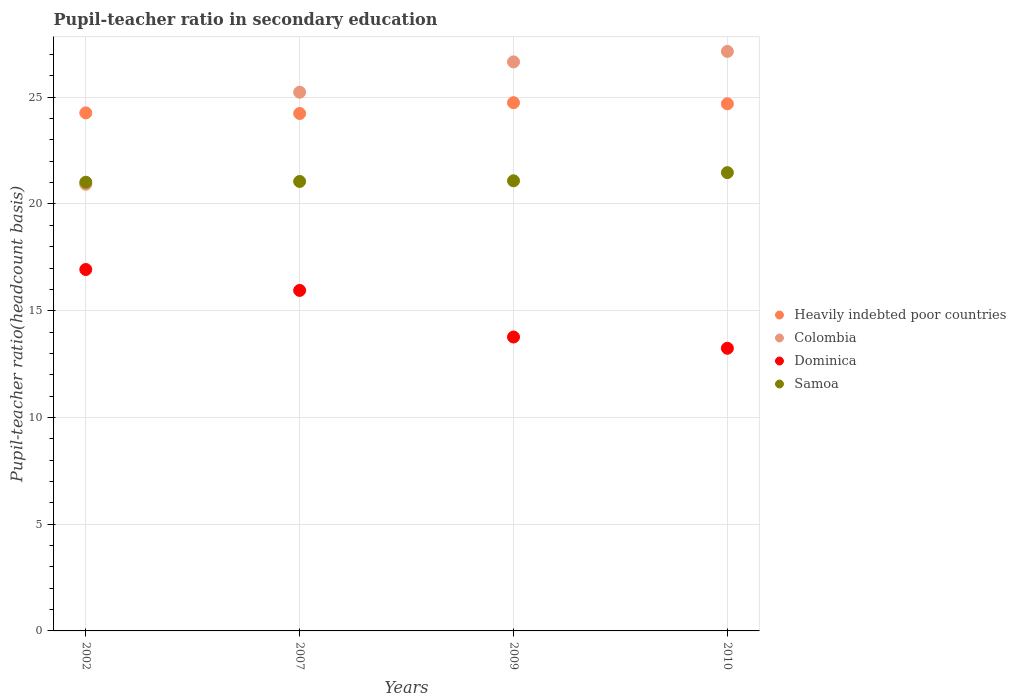What is the pupil-teacher ratio in secondary education in Dominica in 2007?
Your answer should be very brief. 15.95. Across all years, what is the maximum pupil-teacher ratio in secondary education in Colombia?
Your response must be concise. 27.15. Across all years, what is the minimum pupil-teacher ratio in secondary education in Dominica?
Give a very brief answer. 13.24. In which year was the pupil-teacher ratio in secondary education in Dominica maximum?
Offer a very short reply. 2002. In which year was the pupil-teacher ratio in secondary education in Heavily indebted poor countries minimum?
Your response must be concise. 2007. What is the total pupil-teacher ratio in secondary education in Samoa in the graph?
Give a very brief answer. 84.63. What is the difference between the pupil-teacher ratio in secondary education in Colombia in 2007 and that in 2009?
Ensure brevity in your answer.  -1.42. What is the difference between the pupil-teacher ratio in secondary education in Heavily indebted poor countries in 2007 and the pupil-teacher ratio in secondary education in Samoa in 2009?
Your answer should be compact. 3.15. What is the average pupil-teacher ratio in secondary education in Heavily indebted poor countries per year?
Provide a short and direct response. 24.49. In the year 2009, what is the difference between the pupil-teacher ratio in secondary education in Heavily indebted poor countries and pupil-teacher ratio in secondary education in Colombia?
Your response must be concise. -1.91. In how many years, is the pupil-teacher ratio in secondary education in Samoa greater than 11?
Provide a short and direct response. 4. What is the ratio of the pupil-teacher ratio in secondary education in Dominica in 2007 to that in 2010?
Ensure brevity in your answer.  1.2. Is the pupil-teacher ratio in secondary education in Heavily indebted poor countries in 2007 less than that in 2010?
Provide a succinct answer. Yes. What is the difference between the highest and the second highest pupil-teacher ratio in secondary education in Heavily indebted poor countries?
Provide a succinct answer. 0.05. What is the difference between the highest and the lowest pupil-teacher ratio in secondary education in Samoa?
Your response must be concise. 0.45. Is the sum of the pupil-teacher ratio in secondary education in Colombia in 2009 and 2010 greater than the maximum pupil-teacher ratio in secondary education in Samoa across all years?
Ensure brevity in your answer.  Yes. Is it the case that in every year, the sum of the pupil-teacher ratio in secondary education in Samoa and pupil-teacher ratio in secondary education in Dominica  is greater than the sum of pupil-teacher ratio in secondary education in Heavily indebted poor countries and pupil-teacher ratio in secondary education in Colombia?
Your answer should be very brief. No. Is the pupil-teacher ratio in secondary education in Colombia strictly greater than the pupil-teacher ratio in secondary education in Samoa over the years?
Make the answer very short. No. How many dotlines are there?
Ensure brevity in your answer.  4. Are the values on the major ticks of Y-axis written in scientific E-notation?
Your response must be concise. No. Where does the legend appear in the graph?
Offer a terse response. Center right. What is the title of the graph?
Provide a succinct answer. Pupil-teacher ratio in secondary education. Does "Sudan" appear as one of the legend labels in the graph?
Keep it short and to the point. No. What is the label or title of the Y-axis?
Provide a succinct answer. Pupil-teacher ratio(headcount basis). What is the Pupil-teacher ratio(headcount basis) in Heavily indebted poor countries in 2002?
Your answer should be compact. 24.27. What is the Pupil-teacher ratio(headcount basis) of Colombia in 2002?
Your answer should be compact. 20.92. What is the Pupil-teacher ratio(headcount basis) of Dominica in 2002?
Offer a very short reply. 16.93. What is the Pupil-teacher ratio(headcount basis) in Samoa in 2002?
Provide a short and direct response. 21.02. What is the Pupil-teacher ratio(headcount basis) of Heavily indebted poor countries in 2007?
Your response must be concise. 24.24. What is the Pupil-teacher ratio(headcount basis) of Colombia in 2007?
Offer a terse response. 25.23. What is the Pupil-teacher ratio(headcount basis) in Dominica in 2007?
Offer a terse response. 15.95. What is the Pupil-teacher ratio(headcount basis) of Samoa in 2007?
Provide a succinct answer. 21.05. What is the Pupil-teacher ratio(headcount basis) of Heavily indebted poor countries in 2009?
Provide a succinct answer. 24.75. What is the Pupil-teacher ratio(headcount basis) of Colombia in 2009?
Make the answer very short. 26.66. What is the Pupil-teacher ratio(headcount basis) in Dominica in 2009?
Offer a very short reply. 13.77. What is the Pupil-teacher ratio(headcount basis) in Samoa in 2009?
Your answer should be very brief. 21.09. What is the Pupil-teacher ratio(headcount basis) of Heavily indebted poor countries in 2010?
Your answer should be very brief. 24.69. What is the Pupil-teacher ratio(headcount basis) of Colombia in 2010?
Your answer should be very brief. 27.15. What is the Pupil-teacher ratio(headcount basis) in Dominica in 2010?
Provide a succinct answer. 13.24. What is the Pupil-teacher ratio(headcount basis) in Samoa in 2010?
Your response must be concise. 21.47. Across all years, what is the maximum Pupil-teacher ratio(headcount basis) in Heavily indebted poor countries?
Keep it short and to the point. 24.75. Across all years, what is the maximum Pupil-teacher ratio(headcount basis) in Colombia?
Your answer should be very brief. 27.15. Across all years, what is the maximum Pupil-teacher ratio(headcount basis) of Dominica?
Your answer should be compact. 16.93. Across all years, what is the maximum Pupil-teacher ratio(headcount basis) in Samoa?
Make the answer very short. 21.47. Across all years, what is the minimum Pupil-teacher ratio(headcount basis) in Heavily indebted poor countries?
Give a very brief answer. 24.24. Across all years, what is the minimum Pupil-teacher ratio(headcount basis) of Colombia?
Give a very brief answer. 20.92. Across all years, what is the minimum Pupil-teacher ratio(headcount basis) of Dominica?
Your answer should be compact. 13.24. Across all years, what is the minimum Pupil-teacher ratio(headcount basis) in Samoa?
Your response must be concise. 21.02. What is the total Pupil-teacher ratio(headcount basis) in Heavily indebted poor countries in the graph?
Offer a terse response. 97.94. What is the total Pupil-teacher ratio(headcount basis) in Colombia in the graph?
Offer a terse response. 99.96. What is the total Pupil-teacher ratio(headcount basis) in Dominica in the graph?
Provide a succinct answer. 59.89. What is the total Pupil-teacher ratio(headcount basis) in Samoa in the graph?
Your answer should be compact. 84.63. What is the difference between the Pupil-teacher ratio(headcount basis) in Heavily indebted poor countries in 2002 and that in 2007?
Ensure brevity in your answer.  0.03. What is the difference between the Pupil-teacher ratio(headcount basis) of Colombia in 2002 and that in 2007?
Offer a terse response. -4.31. What is the difference between the Pupil-teacher ratio(headcount basis) in Dominica in 2002 and that in 2007?
Ensure brevity in your answer.  0.98. What is the difference between the Pupil-teacher ratio(headcount basis) in Samoa in 2002 and that in 2007?
Offer a very short reply. -0.04. What is the difference between the Pupil-teacher ratio(headcount basis) of Heavily indebted poor countries in 2002 and that in 2009?
Provide a succinct answer. -0.48. What is the difference between the Pupil-teacher ratio(headcount basis) in Colombia in 2002 and that in 2009?
Keep it short and to the point. -5.73. What is the difference between the Pupil-teacher ratio(headcount basis) in Dominica in 2002 and that in 2009?
Provide a short and direct response. 3.16. What is the difference between the Pupil-teacher ratio(headcount basis) in Samoa in 2002 and that in 2009?
Offer a very short reply. -0.07. What is the difference between the Pupil-teacher ratio(headcount basis) of Heavily indebted poor countries in 2002 and that in 2010?
Make the answer very short. -0.43. What is the difference between the Pupil-teacher ratio(headcount basis) in Colombia in 2002 and that in 2010?
Your answer should be very brief. -6.22. What is the difference between the Pupil-teacher ratio(headcount basis) in Dominica in 2002 and that in 2010?
Ensure brevity in your answer.  3.69. What is the difference between the Pupil-teacher ratio(headcount basis) of Samoa in 2002 and that in 2010?
Your answer should be very brief. -0.45. What is the difference between the Pupil-teacher ratio(headcount basis) of Heavily indebted poor countries in 2007 and that in 2009?
Make the answer very short. -0.51. What is the difference between the Pupil-teacher ratio(headcount basis) of Colombia in 2007 and that in 2009?
Keep it short and to the point. -1.42. What is the difference between the Pupil-teacher ratio(headcount basis) in Dominica in 2007 and that in 2009?
Provide a short and direct response. 2.18. What is the difference between the Pupil-teacher ratio(headcount basis) of Samoa in 2007 and that in 2009?
Your response must be concise. -0.03. What is the difference between the Pupil-teacher ratio(headcount basis) of Heavily indebted poor countries in 2007 and that in 2010?
Offer a terse response. -0.45. What is the difference between the Pupil-teacher ratio(headcount basis) of Colombia in 2007 and that in 2010?
Your answer should be very brief. -1.91. What is the difference between the Pupil-teacher ratio(headcount basis) in Dominica in 2007 and that in 2010?
Keep it short and to the point. 2.71. What is the difference between the Pupil-teacher ratio(headcount basis) in Samoa in 2007 and that in 2010?
Offer a terse response. -0.41. What is the difference between the Pupil-teacher ratio(headcount basis) of Heavily indebted poor countries in 2009 and that in 2010?
Provide a succinct answer. 0.05. What is the difference between the Pupil-teacher ratio(headcount basis) in Colombia in 2009 and that in 2010?
Your answer should be very brief. -0.49. What is the difference between the Pupil-teacher ratio(headcount basis) in Dominica in 2009 and that in 2010?
Offer a very short reply. 0.53. What is the difference between the Pupil-teacher ratio(headcount basis) in Samoa in 2009 and that in 2010?
Offer a very short reply. -0.38. What is the difference between the Pupil-teacher ratio(headcount basis) of Heavily indebted poor countries in 2002 and the Pupil-teacher ratio(headcount basis) of Colombia in 2007?
Your answer should be compact. -0.97. What is the difference between the Pupil-teacher ratio(headcount basis) in Heavily indebted poor countries in 2002 and the Pupil-teacher ratio(headcount basis) in Dominica in 2007?
Provide a short and direct response. 8.32. What is the difference between the Pupil-teacher ratio(headcount basis) in Heavily indebted poor countries in 2002 and the Pupil-teacher ratio(headcount basis) in Samoa in 2007?
Provide a succinct answer. 3.21. What is the difference between the Pupil-teacher ratio(headcount basis) in Colombia in 2002 and the Pupil-teacher ratio(headcount basis) in Dominica in 2007?
Give a very brief answer. 4.97. What is the difference between the Pupil-teacher ratio(headcount basis) in Colombia in 2002 and the Pupil-teacher ratio(headcount basis) in Samoa in 2007?
Offer a terse response. -0.13. What is the difference between the Pupil-teacher ratio(headcount basis) of Dominica in 2002 and the Pupil-teacher ratio(headcount basis) of Samoa in 2007?
Provide a short and direct response. -4.12. What is the difference between the Pupil-teacher ratio(headcount basis) of Heavily indebted poor countries in 2002 and the Pupil-teacher ratio(headcount basis) of Colombia in 2009?
Your answer should be very brief. -2.39. What is the difference between the Pupil-teacher ratio(headcount basis) of Heavily indebted poor countries in 2002 and the Pupil-teacher ratio(headcount basis) of Dominica in 2009?
Ensure brevity in your answer.  10.5. What is the difference between the Pupil-teacher ratio(headcount basis) of Heavily indebted poor countries in 2002 and the Pupil-teacher ratio(headcount basis) of Samoa in 2009?
Give a very brief answer. 3.18. What is the difference between the Pupil-teacher ratio(headcount basis) in Colombia in 2002 and the Pupil-teacher ratio(headcount basis) in Dominica in 2009?
Provide a short and direct response. 7.16. What is the difference between the Pupil-teacher ratio(headcount basis) in Colombia in 2002 and the Pupil-teacher ratio(headcount basis) in Samoa in 2009?
Offer a terse response. -0.16. What is the difference between the Pupil-teacher ratio(headcount basis) of Dominica in 2002 and the Pupil-teacher ratio(headcount basis) of Samoa in 2009?
Provide a short and direct response. -4.16. What is the difference between the Pupil-teacher ratio(headcount basis) of Heavily indebted poor countries in 2002 and the Pupil-teacher ratio(headcount basis) of Colombia in 2010?
Offer a terse response. -2.88. What is the difference between the Pupil-teacher ratio(headcount basis) in Heavily indebted poor countries in 2002 and the Pupil-teacher ratio(headcount basis) in Dominica in 2010?
Keep it short and to the point. 11.03. What is the difference between the Pupil-teacher ratio(headcount basis) in Heavily indebted poor countries in 2002 and the Pupil-teacher ratio(headcount basis) in Samoa in 2010?
Keep it short and to the point. 2.8. What is the difference between the Pupil-teacher ratio(headcount basis) in Colombia in 2002 and the Pupil-teacher ratio(headcount basis) in Dominica in 2010?
Give a very brief answer. 7.68. What is the difference between the Pupil-teacher ratio(headcount basis) of Colombia in 2002 and the Pupil-teacher ratio(headcount basis) of Samoa in 2010?
Your answer should be very brief. -0.54. What is the difference between the Pupil-teacher ratio(headcount basis) of Dominica in 2002 and the Pupil-teacher ratio(headcount basis) of Samoa in 2010?
Your answer should be very brief. -4.54. What is the difference between the Pupil-teacher ratio(headcount basis) of Heavily indebted poor countries in 2007 and the Pupil-teacher ratio(headcount basis) of Colombia in 2009?
Make the answer very short. -2.42. What is the difference between the Pupil-teacher ratio(headcount basis) in Heavily indebted poor countries in 2007 and the Pupil-teacher ratio(headcount basis) in Dominica in 2009?
Your answer should be very brief. 10.47. What is the difference between the Pupil-teacher ratio(headcount basis) of Heavily indebted poor countries in 2007 and the Pupil-teacher ratio(headcount basis) of Samoa in 2009?
Ensure brevity in your answer.  3.15. What is the difference between the Pupil-teacher ratio(headcount basis) in Colombia in 2007 and the Pupil-teacher ratio(headcount basis) in Dominica in 2009?
Provide a short and direct response. 11.47. What is the difference between the Pupil-teacher ratio(headcount basis) of Colombia in 2007 and the Pupil-teacher ratio(headcount basis) of Samoa in 2009?
Your answer should be compact. 4.15. What is the difference between the Pupil-teacher ratio(headcount basis) of Dominica in 2007 and the Pupil-teacher ratio(headcount basis) of Samoa in 2009?
Make the answer very short. -5.13. What is the difference between the Pupil-teacher ratio(headcount basis) of Heavily indebted poor countries in 2007 and the Pupil-teacher ratio(headcount basis) of Colombia in 2010?
Offer a very short reply. -2.91. What is the difference between the Pupil-teacher ratio(headcount basis) of Heavily indebted poor countries in 2007 and the Pupil-teacher ratio(headcount basis) of Dominica in 2010?
Offer a very short reply. 11. What is the difference between the Pupil-teacher ratio(headcount basis) in Heavily indebted poor countries in 2007 and the Pupil-teacher ratio(headcount basis) in Samoa in 2010?
Ensure brevity in your answer.  2.77. What is the difference between the Pupil-teacher ratio(headcount basis) in Colombia in 2007 and the Pupil-teacher ratio(headcount basis) in Dominica in 2010?
Give a very brief answer. 11.99. What is the difference between the Pupil-teacher ratio(headcount basis) in Colombia in 2007 and the Pupil-teacher ratio(headcount basis) in Samoa in 2010?
Give a very brief answer. 3.77. What is the difference between the Pupil-teacher ratio(headcount basis) in Dominica in 2007 and the Pupil-teacher ratio(headcount basis) in Samoa in 2010?
Provide a short and direct response. -5.52. What is the difference between the Pupil-teacher ratio(headcount basis) of Heavily indebted poor countries in 2009 and the Pupil-teacher ratio(headcount basis) of Colombia in 2010?
Make the answer very short. -2.4. What is the difference between the Pupil-teacher ratio(headcount basis) of Heavily indebted poor countries in 2009 and the Pupil-teacher ratio(headcount basis) of Dominica in 2010?
Your response must be concise. 11.5. What is the difference between the Pupil-teacher ratio(headcount basis) of Heavily indebted poor countries in 2009 and the Pupil-teacher ratio(headcount basis) of Samoa in 2010?
Your answer should be compact. 3.28. What is the difference between the Pupil-teacher ratio(headcount basis) in Colombia in 2009 and the Pupil-teacher ratio(headcount basis) in Dominica in 2010?
Your answer should be very brief. 13.42. What is the difference between the Pupil-teacher ratio(headcount basis) of Colombia in 2009 and the Pupil-teacher ratio(headcount basis) of Samoa in 2010?
Your answer should be very brief. 5.19. What is the difference between the Pupil-teacher ratio(headcount basis) of Dominica in 2009 and the Pupil-teacher ratio(headcount basis) of Samoa in 2010?
Offer a very short reply. -7.7. What is the average Pupil-teacher ratio(headcount basis) of Heavily indebted poor countries per year?
Offer a terse response. 24.49. What is the average Pupil-teacher ratio(headcount basis) of Colombia per year?
Your response must be concise. 24.99. What is the average Pupil-teacher ratio(headcount basis) in Dominica per year?
Make the answer very short. 14.97. What is the average Pupil-teacher ratio(headcount basis) in Samoa per year?
Provide a short and direct response. 21.16. In the year 2002, what is the difference between the Pupil-teacher ratio(headcount basis) of Heavily indebted poor countries and Pupil-teacher ratio(headcount basis) of Colombia?
Your response must be concise. 3.34. In the year 2002, what is the difference between the Pupil-teacher ratio(headcount basis) in Heavily indebted poor countries and Pupil-teacher ratio(headcount basis) in Dominica?
Make the answer very short. 7.34. In the year 2002, what is the difference between the Pupil-teacher ratio(headcount basis) in Heavily indebted poor countries and Pupil-teacher ratio(headcount basis) in Samoa?
Offer a terse response. 3.25. In the year 2002, what is the difference between the Pupil-teacher ratio(headcount basis) in Colombia and Pupil-teacher ratio(headcount basis) in Dominica?
Offer a very short reply. 3.99. In the year 2002, what is the difference between the Pupil-teacher ratio(headcount basis) in Colombia and Pupil-teacher ratio(headcount basis) in Samoa?
Your answer should be very brief. -0.09. In the year 2002, what is the difference between the Pupil-teacher ratio(headcount basis) of Dominica and Pupil-teacher ratio(headcount basis) of Samoa?
Give a very brief answer. -4.09. In the year 2007, what is the difference between the Pupil-teacher ratio(headcount basis) in Heavily indebted poor countries and Pupil-teacher ratio(headcount basis) in Colombia?
Offer a terse response. -1. In the year 2007, what is the difference between the Pupil-teacher ratio(headcount basis) of Heavily indebted poor countries and Pupil-teacher ratio(headcount basis) of Dominica?
Give a very brief answer. 8.29. In the year 2007, what is the difference between the Pupil-teacher ratio(headcount basis) in Heavily indebted poor countries and Pupil-teacher ratio(headcount basis) in Samoa?
Your answer should be compact. 3.18. In the year 2007, what is the difference between the Pupil-teacher ratio(headcount basis) in Colombia and Pupil-teacher ratio(headcount basis) in Dominica?
Provide a short and direct response. 9.28. In the year 2007, what is the difference between the Pupil-teacher ratio(headcount basis) of Colombia and Pupil-teacher ratio(headcount basis) of Samoa?
Provide a succinct answer. 4.18. In the year 2007, what is the difference between the Pupil-teacher ratio(headcount basis) of Dominica and Pupil-teacher ratio(headcount basis) of Samoa?
Your answer should be very brief. -5.1. In the year 2009, what is the difference between the Pupil-teacher ratio(headcount basis) in Heavily indebted poor countries and Pupil-teacher ratio(headcount basis) in Colombia?
Keep it short and to the point. -1.91. In the year 2009, what is the difference between the Pupil-teacher ratio(headcount basis) of Heavily indebted poor countries and Pupil-teacher ratio(headcount basis) of Dominica?
Provide a succinct answer. 10.98. In the year 2009, what is the difference between the Pupil-teacher ratio(headcount basis) of Heavily indebted poor countries and Pupil-teacher ratio(headcount basis) of Samoa?
Your answer should be very brief. 3.66. In the year 2009, what is the difference between the Pupil-teacher ratio(headcount basis) of Colombia and Pupil-teacher ratio(headcount basis) of Dominica?
Your answer should be compact. 12.89. In the year 2009, what is the difference between the Pupil-teacher ratio(headcount basis) in Colombia and Pupil-teacher ratio(headcount basis) in Samoa?
Your answer should be compact. 5.57. In the year 2009, what is the difference between the Pupil-teacher ratio(headcount basis) of Dominica and Pupil-teacher ratio(headcount basis) of Samoa?
Make the answer very short. -7.32. In the year 2010, what is the difference between the Pupil-teacher ratio(headcount basis) in Heavily indebted poor countries and Pupil-teacher ratio(headcount basis) in Colombia?
Give a very brief answer. -2.45. In the year 2010, what is the difference between the Pupil-teacher ratio(headcount basis) in Heavily indebted poor countries and Pupil-teacher ratio(headcount basis) in Dominica?
Ensure brevity in your answer.  11.45. In the year 2010, what is the difference between the Pupil-teacher ratio(headcount basis) of Heavily indebted poor countries and Pupil-teacher ratio(headcount basis) of Samoa?
Provide a short and direct response. 3.22. In the year 2010, what is the difference between the Pupil-teacher ratio(headcount basis) of Colombia and Pupil-teacher ratio(headcount basis) of Dominica?
Provide a short and direct response. 13.91. In the year 2010, what is the difference between the Pupil-teacher ratio(headcount basis) of Colombia and Pupil-teacher ratio(headcount basis) of Samoa?
Provide a succinct answer. 5.68. In the year 2010, what is the difference between the Pupil-teacher ratio(headcount basis) in Dominica and Pupil-teacher ratio(headcount basis) in Samoa?
Offer a very short reply. -8.23. What is the ratio of the Pupil-teacher ratio(headcount basis) of Colombia in 2002 to that in 2007?
Provide a succinct answer. 0.83. What is the ratio of the Pupil-teacher ratio(headcount basis) in Dominica in 2002 to that in 2007?
Your answer should be compact. 1.06. What is the ratio of the Pupil-teacher ratio(headcount basis) of Samoa in 2002 to that in 2007?
Your response must be concise. 1. What is the ratio of the Pupil-teacher ratio(headcount basis) in Heavily indebted poor countries in 2002 to that in 2009?
Ensure brevity in your answer.  0.98. What is the ratio of the Pupil-teacher ratio(headcount basis) in Colombia in 2002 to that in 2009?
Offer a terse response. 0.79. What is the ratio of the Pupil-teacher ratio(headcount basis) of Dominica in 2002 to that in 2009?
Give a very brief answer. 1.23. What is the ratio of the Pupil-teacher ratio(headcount basis) of Heavily indebted poor countries in 2002 to that in 2010?
Provide a short and direct response. 0.98. What is the ratio of the Pupil-teacher ratio(headcount basis) in Colombia in 2002 to that in 2010?
Keep it short and to the point. 0.77. What is the ratio of the Pupil-teacher ratio(headcount basis) of Dominica in 2002 to that in 2010?
Keep it short and to the point. 1.28. What is the ratio of the Pupil-teacher ratio(headcount basis) in Samoa in 2002 to that in 2010?
Your answer should be very brief. 0.98. What is the ratio of the Pupil-teacher ratio(headcount basis) of Heavily indebted poor countries in 2007 to that in 2009?
Provide a short and direct response. 0.98. What is the ratio of the Pupil-teacher ratio(headcount basis) of Colombia in 2007 to that in 2009?
Give a very brief answer. 0.95. What is the ratio of the Pupil-teacher ratio(headcount basis) of Dominica in 2007 to that in 2009?
Give a very brief answer. 1.16. What is the ratio of the Pupil-teacher ratio(headcount basis) of Samoa in 2007 to that in 2009?
Make the answer very short. 1. What is the ratio of the Pupil-teacher ratio(headcount basis) in Heavily indebted poor countries in 2007 to that in 2010?
Your answer should be compact. 0.98. What is the ratio of the Pupil-teacher ratio(headcount basis) of Colombia in 2007 to that in 2010?
Provide a short and direct response. 0.93. What is the ratio of the Pupil-teacher ratio(headcount basis) in Dominica in 2007 to that in 2010?
Ensure brevity in your answer.  1.2. What is the ratio of the Pupil-teacher ratio(headcount basis) in Samoa in 2007 to that in 2010?
Your response must be concise. 0.98. What is the ratio of the Pupil-teacher ratio(headcount basis) in Heavily indebted poor countries in 2009 to that in 2010?
Your answer should be very brief. 1. What is the ratio of the Pupil-teacher ratio(headcount basis) of Colombia in 2009 to that in 2010?
Ensure brevity in your answer.  0.98. What is the ratio of the Pupil-teacher ratio(headcount basis) of Dominica in 2009 to that in 2010?
Your answer should be very brief. 1.04. What is the ratio of the Pupil-teacher ratio(headcount basis) in Samoa in 2009 to that in 2010?
Offer a terse response. 0.98. What is the difference between the highest and the second highest Pupil-teacher ratio(headcount basis) of Heavily indebted poor countries?
Make the answer very short. 0.05. What is the difference between the highest and the second highest Pupil-teacher ratio(headcount basis) in Colombia?
Offer a very short reply. 0.49. What is the difference between the highest and the second highest Pupil-teacher ratio(headcount basis) in Dominica?
Offer a very short reply. 0.98. What is the difference between the highest and the second highest Pupil-teacher ratio(headcount basis) in Samoa?
Your answer should be compact. 0.38. What is the difference between the highest and the lowest Pupil-teacher ratio(headcount basis) in Heavily indebted poor countries?
Offer a very short reply. 0.51. What is the difference between the highest and the lowest Pupil-teacher ratio(headcount basis) in Colombia?
Your answer should be compact. 6.22. What is the difference between the highest and the lowest Pupil-teacher ratio(headcount basis) in Dominica?
Your response must be concise. 3.69. What is the difference between the highest and the lowest Pupil-teacher ratio(headcount basis) of Samoa?
Offer a very short reply. 0.45. 